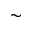Convert formula to latex. <formula><loc_0><loc_0><loc_500><loc_500>\sim</formula> 